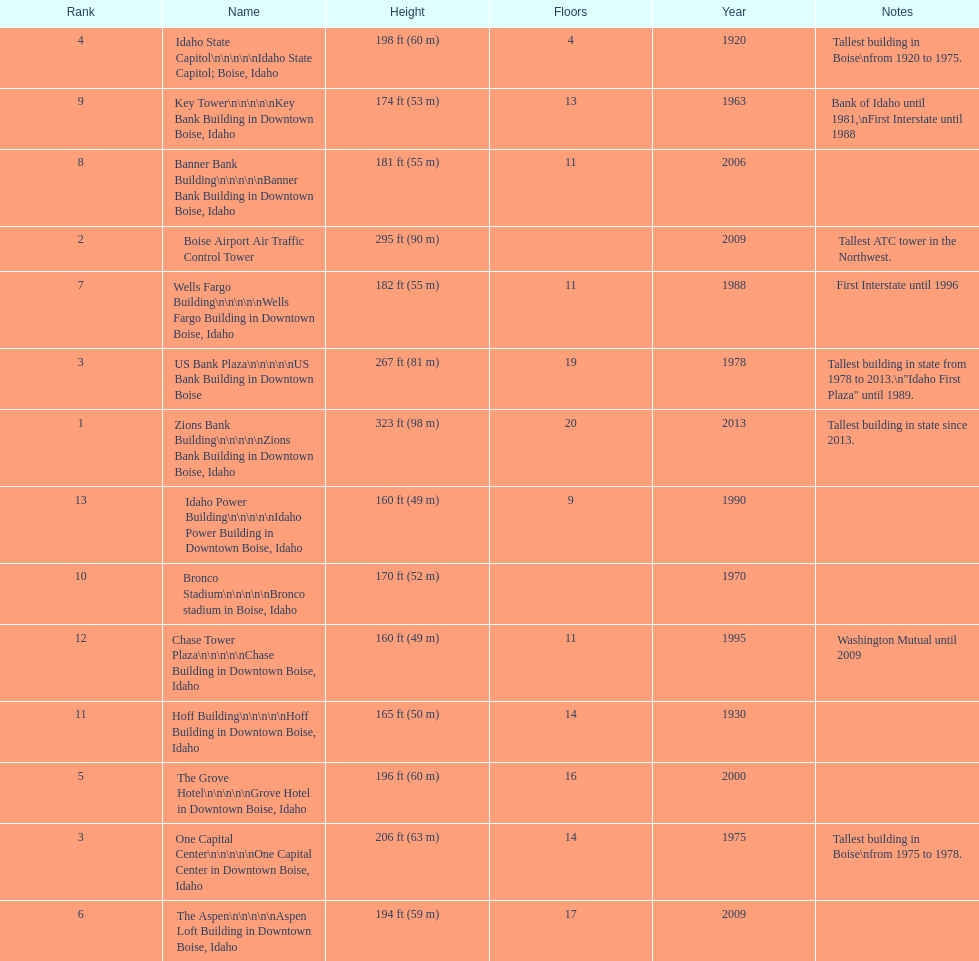What is the tallest building in bosie, idaho? Zions Bank Building Zions Bank Building in Downtown Boise, Idaho. 